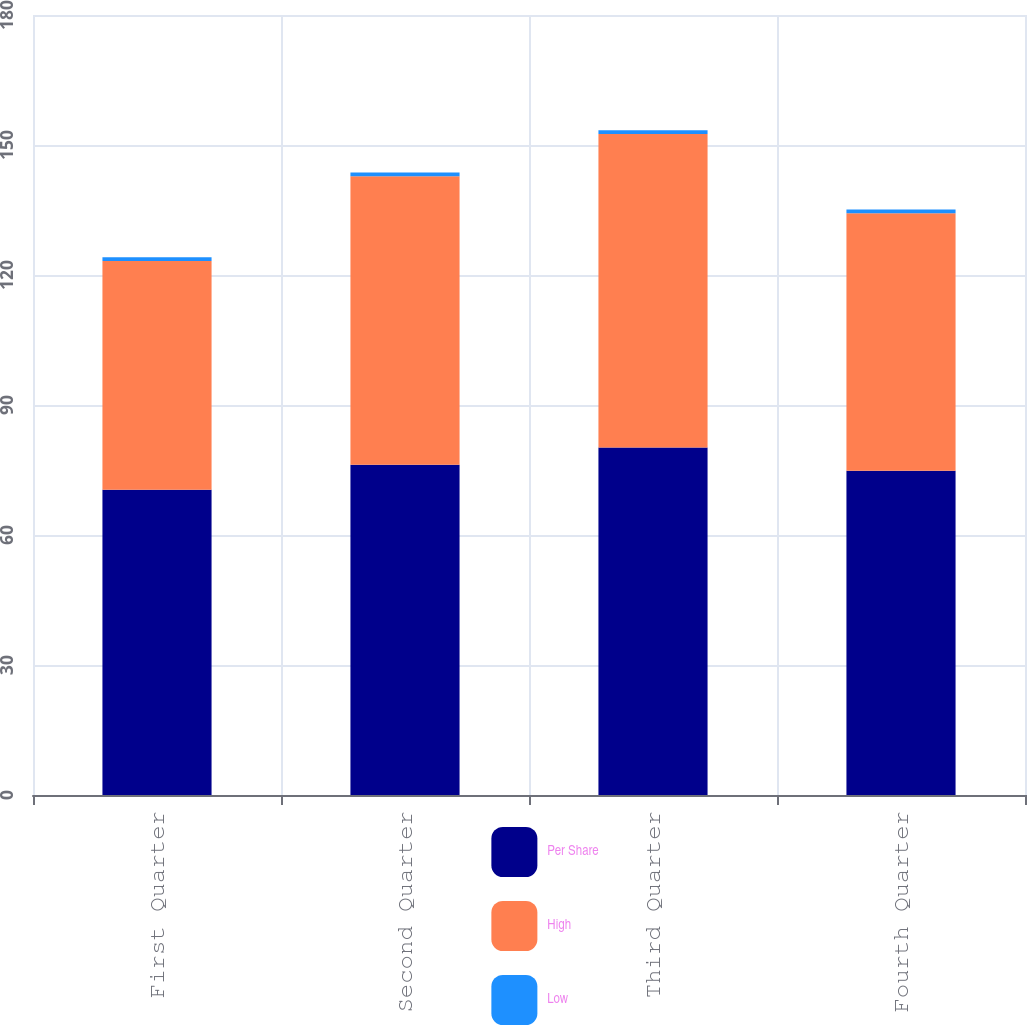<chart> <loc_0><loc_0><loc_500><loc_500><stacked_bar_chart><ecel><fcel>First Quarter<fcel>Second Quarter<fcel>Third Quarter<fcel>Fourth Quarter<nl><fcel>Per Share<fcel>70.45<fcel>76.24<fcel>80.19<fcel>74.85<nl><fcel>High<fcel>52.8<fcel>66.55<fcel>72.34<fcel>59.39<nl><fcel>Low<fcel>0.86<fcel>0.86<fcel>0.86<fcel>0.86<nl></chart> 